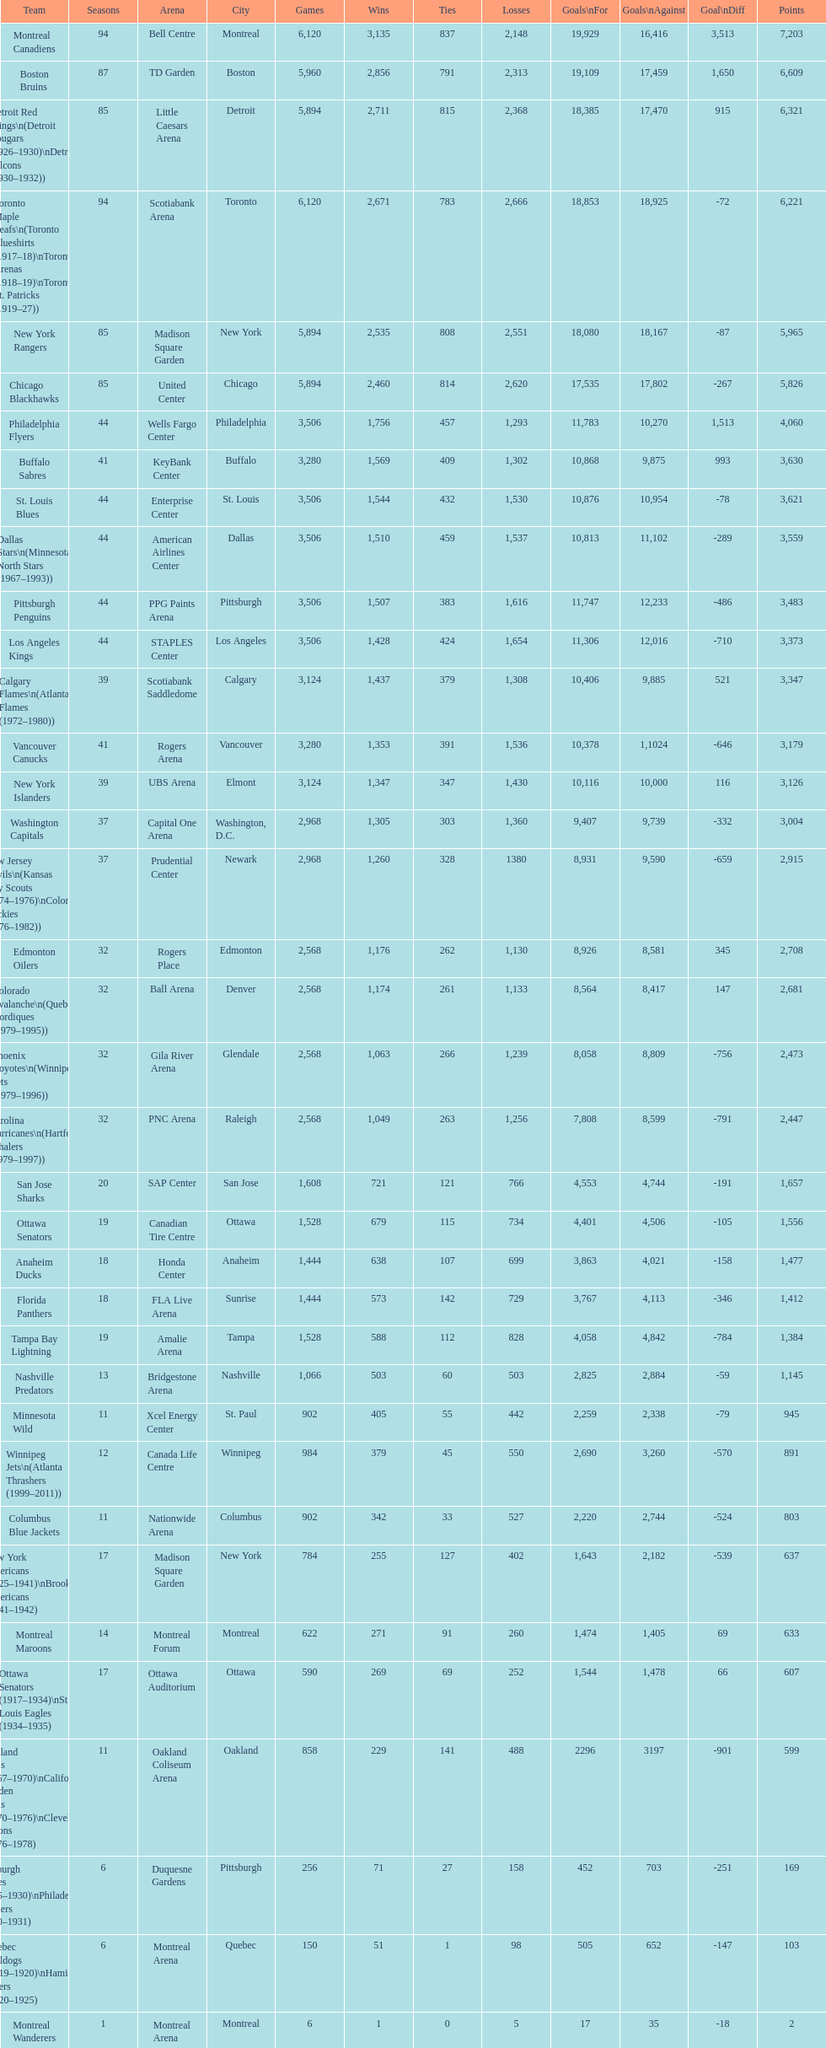Who is at the top of the list? Montreal Canadiens. 